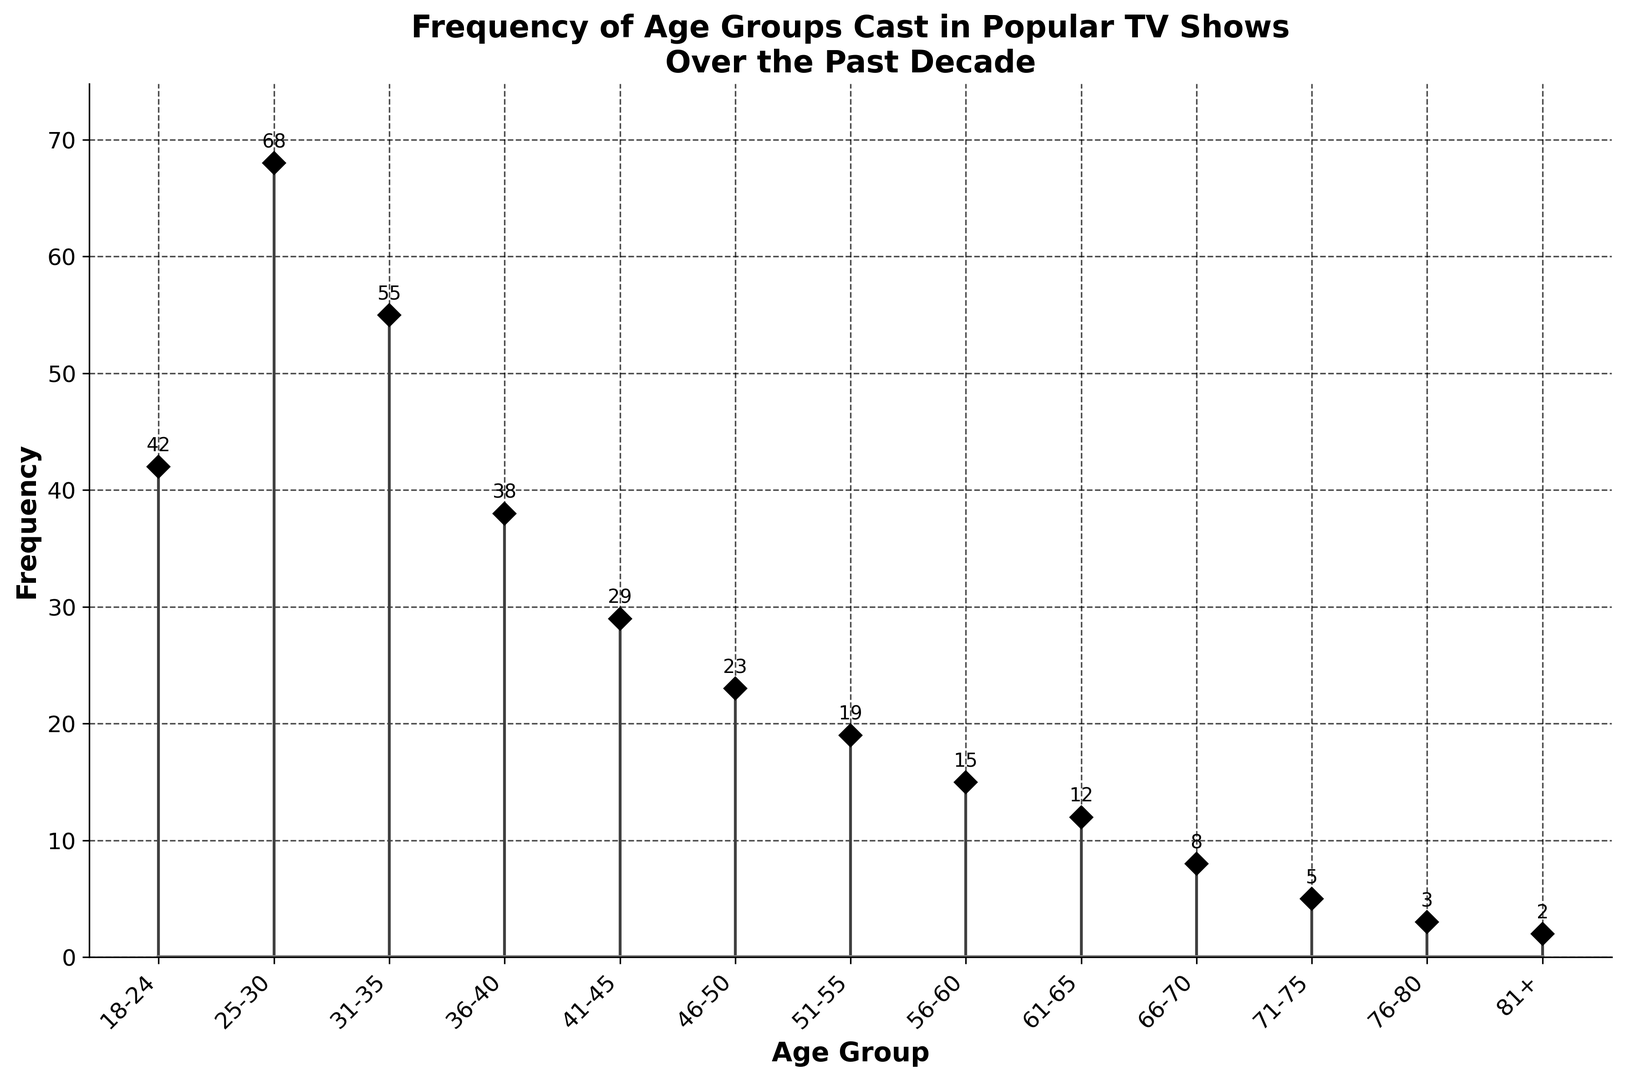What age group appears most frequently in the shows? The age group with the highest frequency has the tallest stem in the plot. The 25-30 age group has a frequency of 68, which is the highest compared to the frequencies of other age groups.
Answer: 25-30 Which age group has the lowest frequency? The shortest stem in the plot indicates the age group with the lowest frequency. The 81+ age group has a frequency of 2, which is the lowest.
Answer: 81+ How much greater is the frequency of the 25-30 age group compared to the 46-50 age group? The frequency of the 25-30 age group is 68, and the frequency of the 46-50 age group is 23. The difference is 68 - 23.
Answer: 45 What is the combined frequency of the age groups 18-24, 56-60, and 61-65? The frequencies for these age groups are 42 (18-24), 15 (56-60), and 12 (61-65). The combined frequency is 42 + 15 + 12.
Answer: 69 What is the average frequency of the age groups from 41-45 to 61-65? The frequencies are 29 (41-45), 23 (46-50), 19 (51-55), 15 (56-60), and 12 (61-65). The average is (29 + 23 + 19 + 15 + 12) / 5.
Answer: 19.6 Which age group has a frequency closest to the median value of all age groups' frequencies? To find the median frequency, first order the frequencies: 2, 3, 5, 8, 12, 15, 19, 23, 29, 38, 42, 55, 68. The median value is the middle one, which is the 7th value, 19. The 51-55 age group has a frequency of 19.
Answer: 51-55 Between which two consecutive age groups is the largest frequency decrease observed? By observing the height difference between consecutive stems, the biggest drop is between the 25-30 age group (68) and the 31-35 age group (55).
Answer: 25-30 to 31-35 How many age groups have a frequency of 30 or higher? Look at the stems to count the ones that reach 30 or more. They represent the age groups 18-24 (42), 25-30 (68), 31-35 (55), and 36-40 (38). So, there are 4 such age groups.
Answer: 4 Is the frequency of the 36-40 age group more than double the frequency of the 61-65 age group? The 36-40 age group has a frequency of 38, and the 61-65 age group has a frequency of 12. Double the 61-65 frequency is 24, and since 38 is greater than 24, the answer is yes.
Answer: Yes 